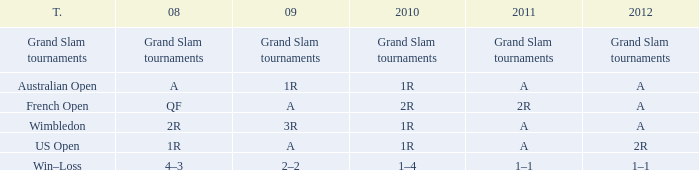Name the 2009 ffor 2010 of 1r and 2012 of a and 2008 of 2r 3R. 